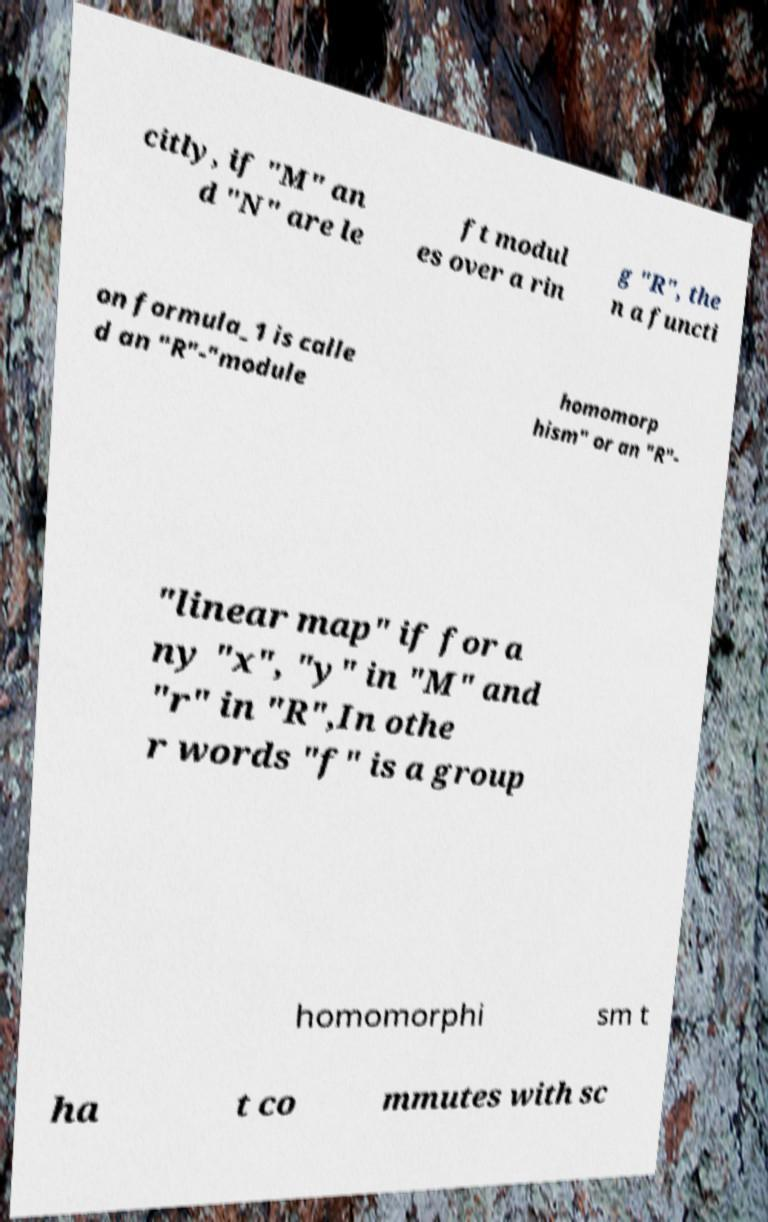Please identify and transcribe the text found in this image. citly, if "M" an d "N" are le ft modul es over a rin g "R", the n a functi on formula_1 is calle d an "R"-"module homomorp hism" or an "R"- "linear map" if for a ny "x", "y" in "M" and "r" in "R",In othe r words "f" is a group homomorphi sm t ha t co mmutes with sc 